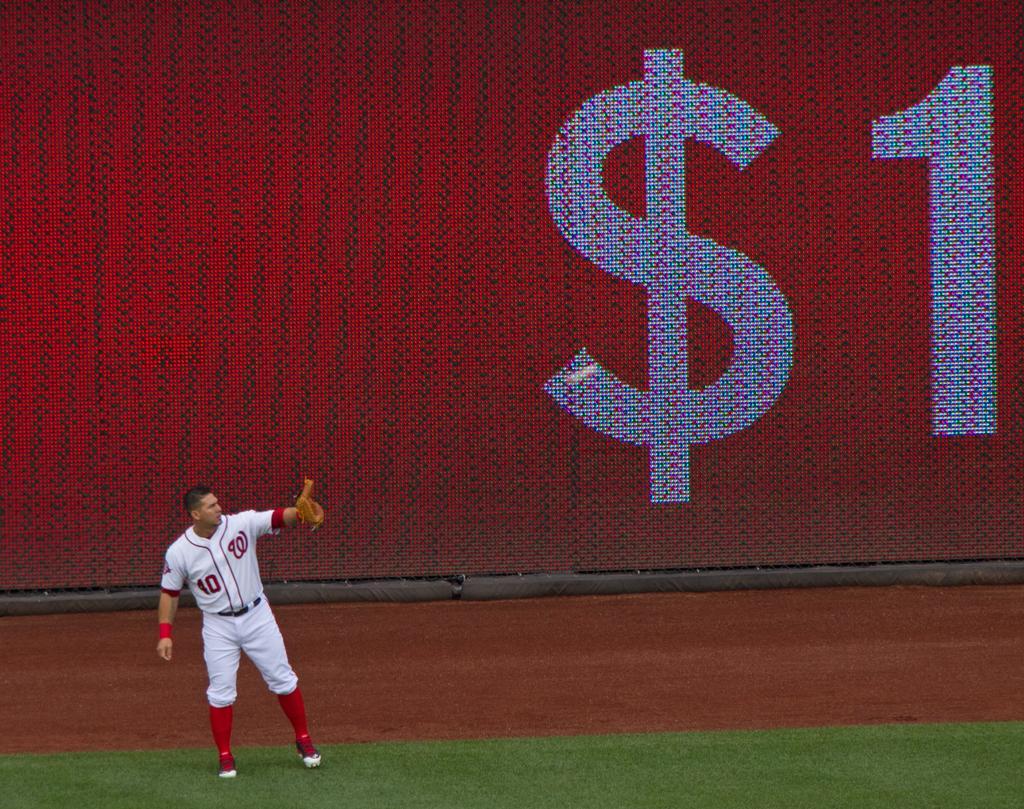In one or two sentences, can you explain what this image depicts? In this image in the front there's grass on the ground. In the center there is a man standing. In the background there is a board with symbol and number written on it. 